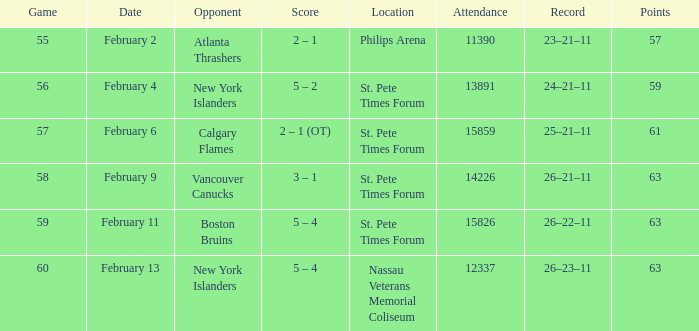What scores happened to be on February 9? 3 – 1. 